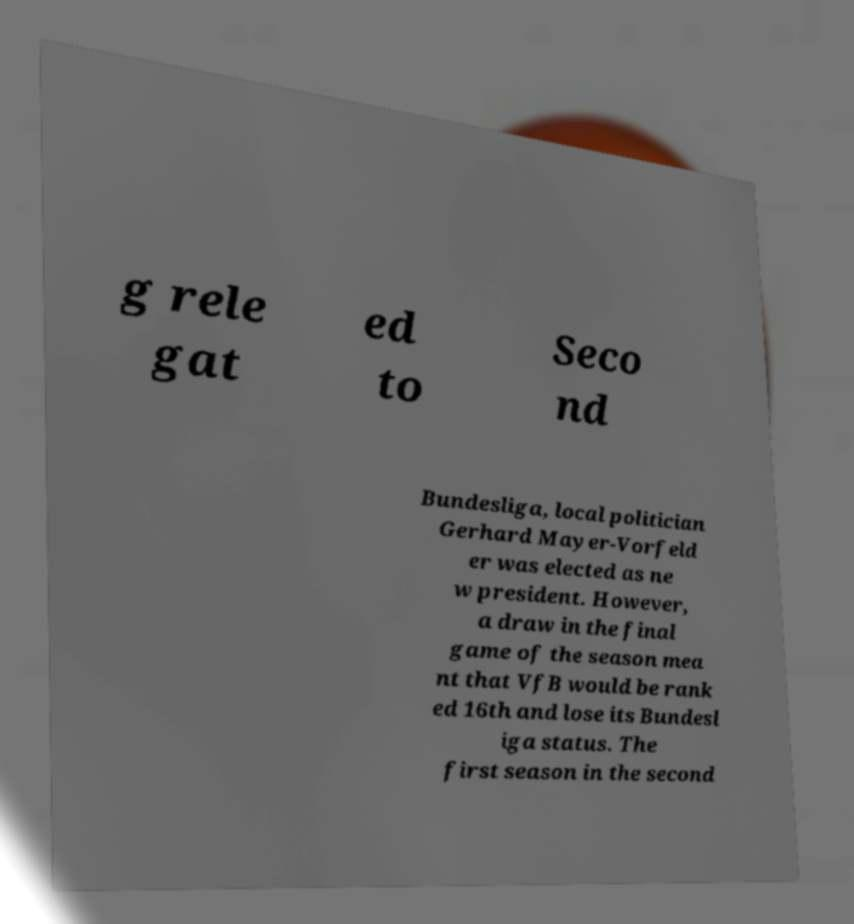What messages or text are displayed in this image? I need them in a readable, typed format. g rele gat ed to Seco nd Bundesliga, local politician Gerhard Mayer-Vorfeld er was elected as ne w president. However, a draw in the final game of the season mea nt that VfB would be rank ed 16th and lose its Bundesl iga status. The first season in the second 